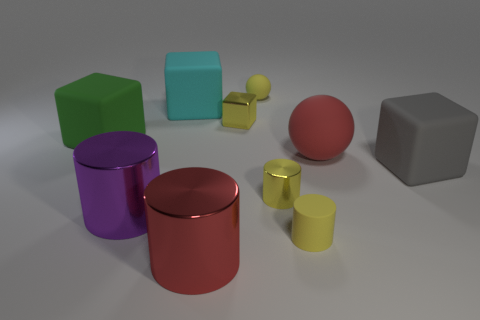What is the shape of the red thing that is to the right of the tiny yellow sphere?
Provide a short and direct response. Sphere. What size is the red thing that is right of the red object that is in front of the small yellow matte cylinder on the right side of the metal cube?
Your answer should be very brief. Large. Does the green matte object have the same shape as the gray object?
Ensure brevity in your answer.  Yes. How big is the object that is both behind the red matte sphere and on the right side of the small yellow cube?
Make the answer very short. Small. There is a cyan thing that is the same shape as the big gray matte object; what material is it?
Keep it short and to the point. Rubber. There is a block right of the big red object that is behind the large purple metallic thing; what is it made of?
Give a very brief answer. Rubber. Does the large gray matte object have the same shape as the tiny yellow matte object in front of the green thing?
Your answer should be very brief. No. What number of metallic things are big cylinders or large gray blocks?
Make the answer very short. 2. What is the color of the tiny metallic thing that is in front of the large matte block that is to the right of the small metallic thing that is behind the big gray cube?
Your answer should be very brief. Yellow. How many other objects are there of the same material as the big red cylinder?
Your answer should be compact. 3. 